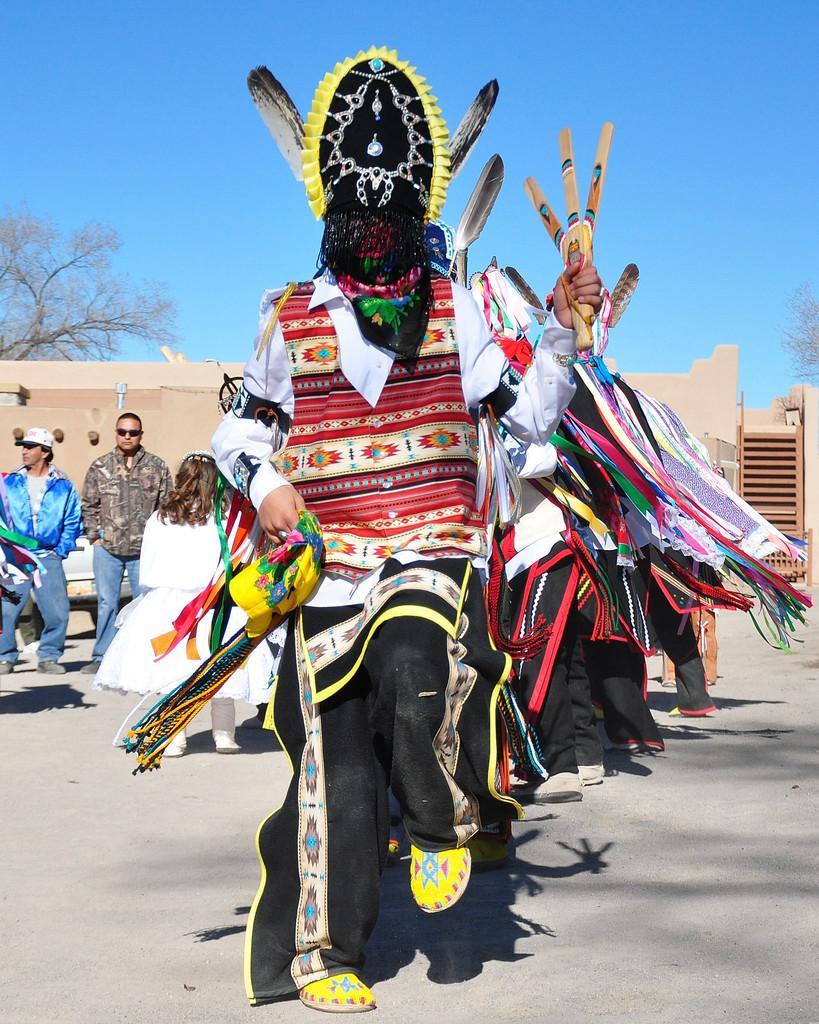Please provide a concise description of this image. In the center of the image we can see people standing. They are wearing costumes. On the left there is a tree. In the background we can see building. We can also see people standing. At the top there is sky. 